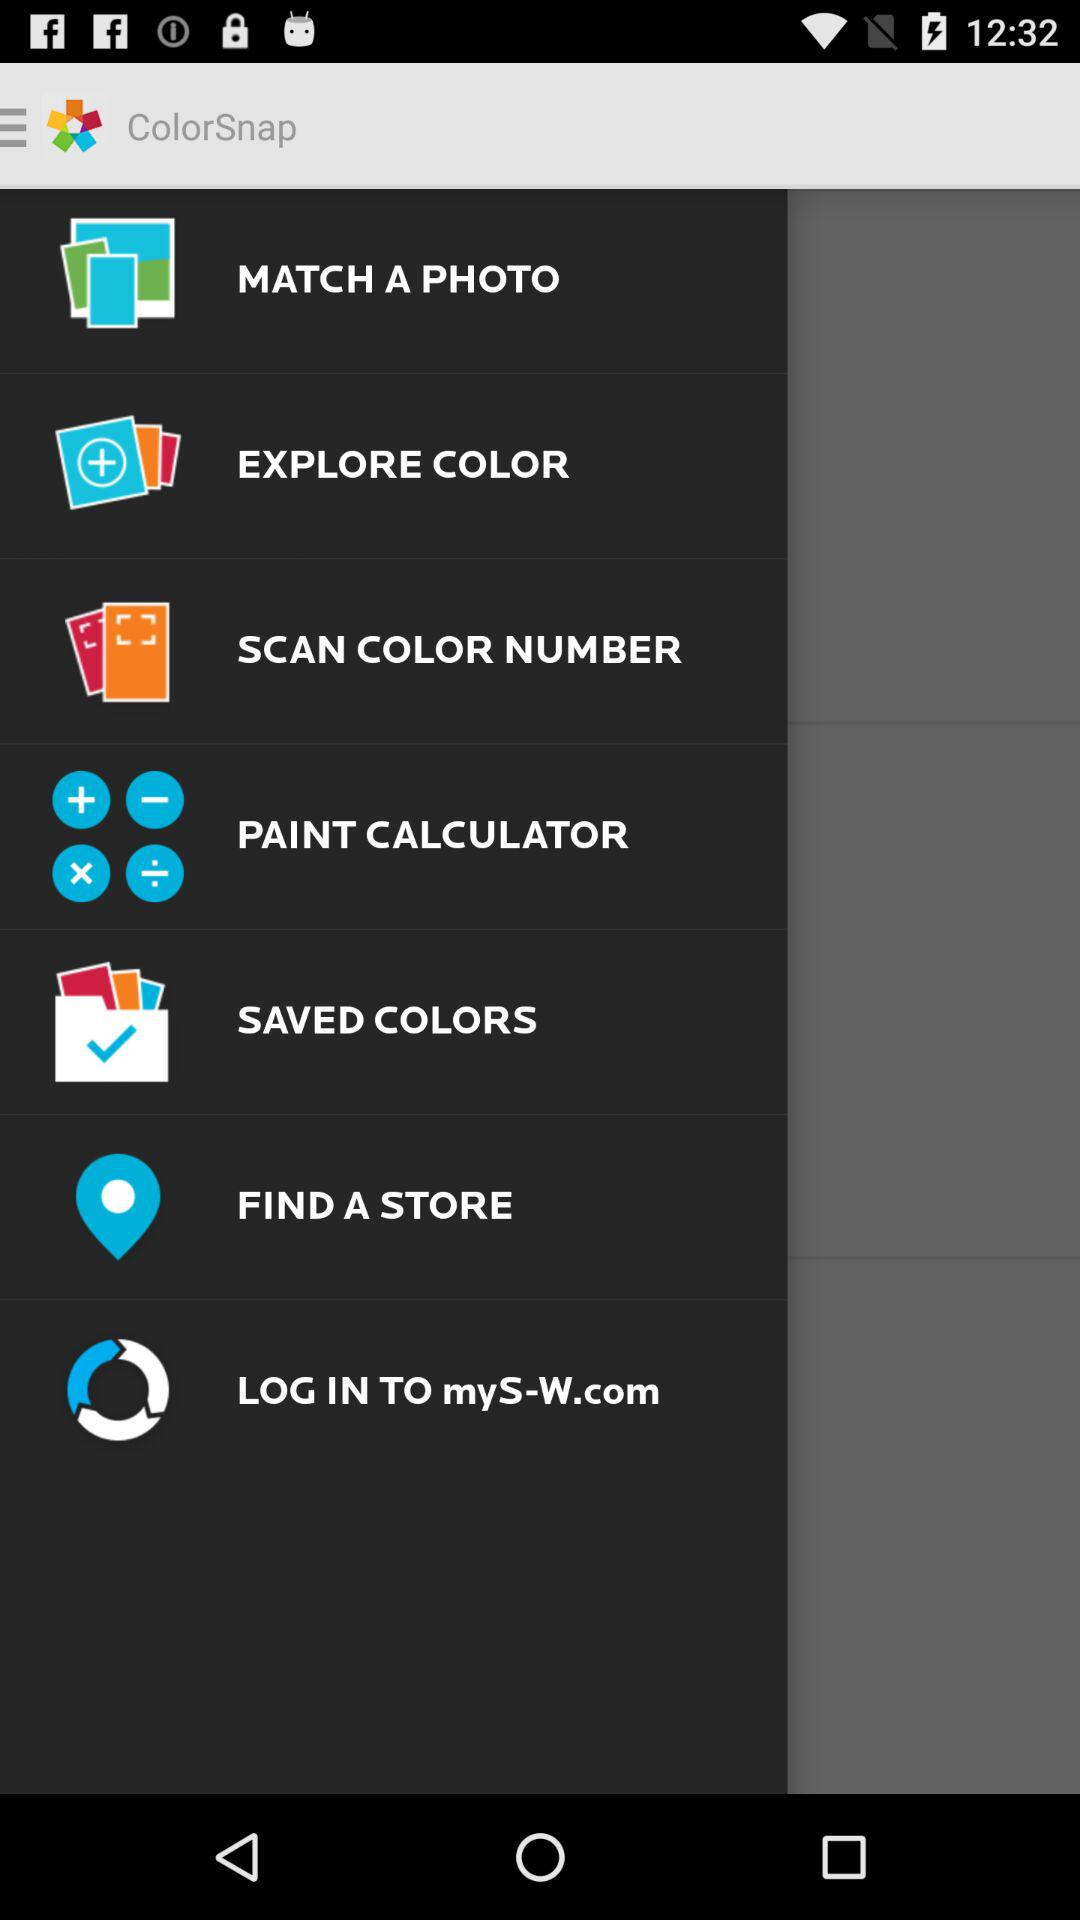Which colors have been saved?
When the provided information is insufficient, respond with <no answer>. <no answer> 